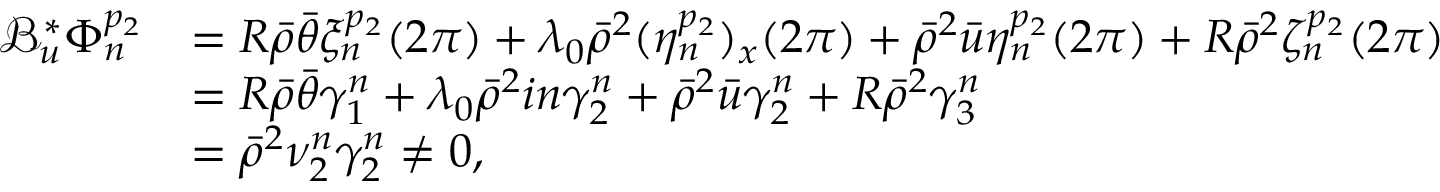Convert formula to latex. <formula><loc_0><loc_0><loc_500><loc_500>\begin{array} { r l } { \mathcal { B } _ { u } ^ { * } \Phi _ { n } ^ { p _ { 2 } } } & { = R \bar { \rho } \bar { \theta } \xi _ { n } ^ { p _ { 2 } } ( 2 \pi ) + \lambda _ { 0 } \bar { \rho } ^ { 2 } ( \eta _ { n } ^ { p _ { 2 } } ) _ { x } ( 2 \pi ) + \bar { \rho } ^ { 2 } \bar { u } \eta _ { n } ^ { p _ { 2 } } ( 2 \pi ) + R \bar { \rho } ^ { 2 } \zeta _ { n } ^ { p _ { 2 } } ( 2 \pi ) } \\ & { = R \bar { \rho } \bar { \theta } \gamma _ { 1 } ^ { n } + \lambda _ { 0 } \bar { \rho } ^ { 2 } i n \gamma _ { 2 } ^ { n } + \bar { \rho } ^ { 2 } \bar { u } \gamma _ { 2 } ^ { n } + R \bar { \rho } ^ { 2 } \gamma _ { 3 } ^ { n } } \\ & { = \bar { \rho } ^ { 2 } \nu _ { 2 } ^ { n } \gamma _ { 2 } ^ { n } \neq 0 , } \end{array}</formula> 